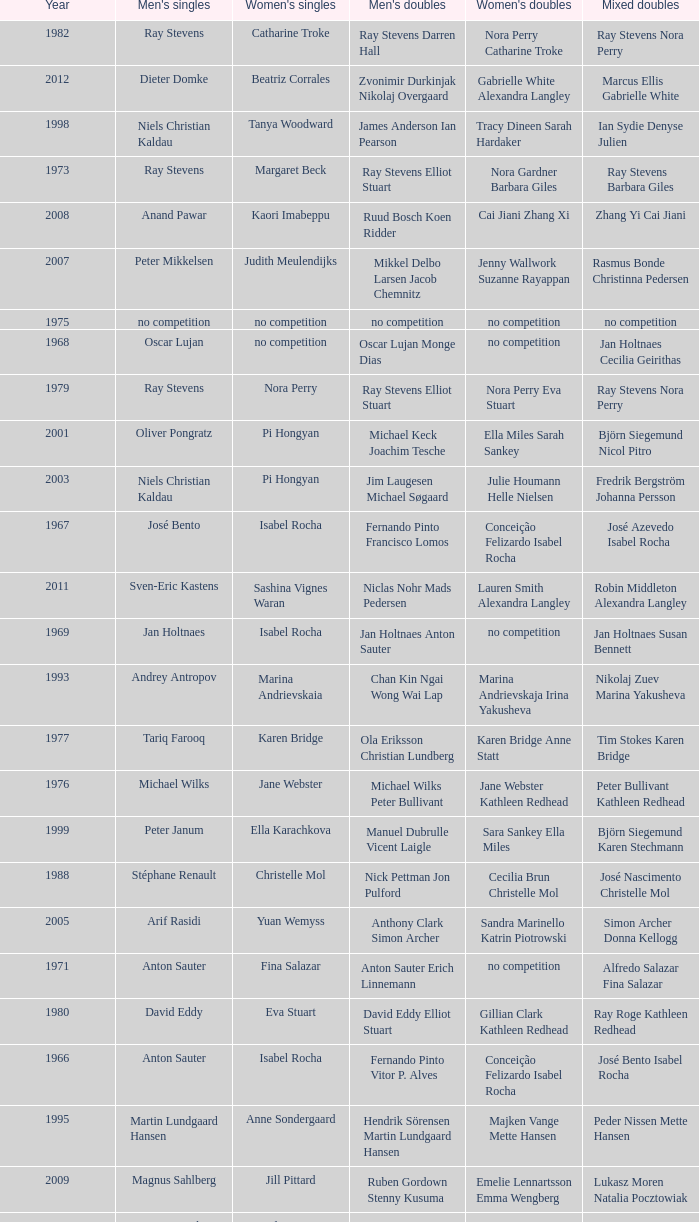What is the average year with alfredo salazar fina salazar in mixed doubles? 1971.0. 